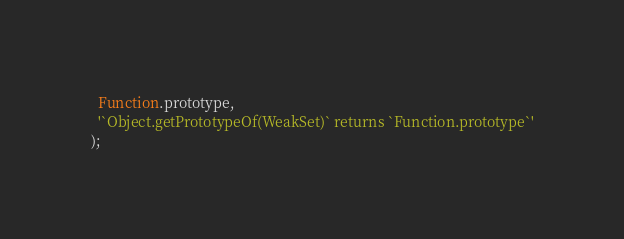<code> <loc_0><loc_0><loc_500><loc_500><_JavaScript_>  Function.prototype,
  '`Object.getPrototypeOf(WeakSet)` returns `Function.prototype`'
);
</code> 